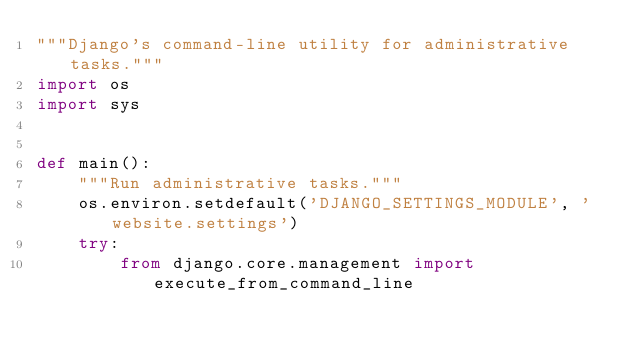Convert code to text. <code><loc_0><loc_0><loc_500><loc_500><_Python_>"""Django's command-line utility for administrative tasks."""
import os
import sys


def main():
    """Run administrative tasks."""
    os.environ.setdefault('DJANGO_SETTINGS_MODULE', 'website.settings')
    try:
        from django.core.management import execute_from_command_line</code> 